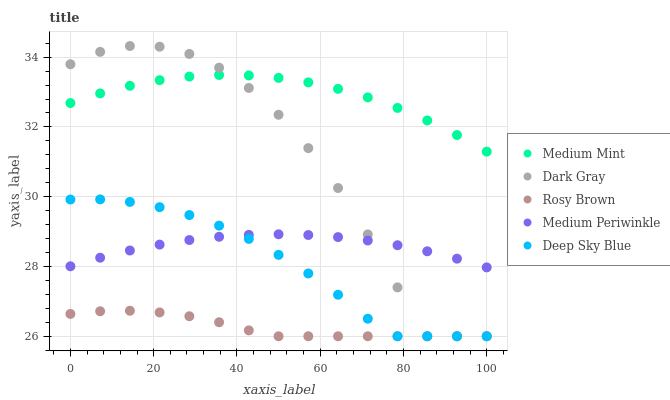Does Rosy Brown have the minimum area under the curve?
Answer yes or no. Yes. Does Medium Mint have the maximum area under the curve?
Answer yes or no. Yes. Does Dark Gray have the minimum area under the curve?
Answer yes or no. No. Does Dark Gray have the maximum area under the curve?
Answer yes or no. No. Is Medium Periwinkle the smoothest?
Answer yes or no. Yes. Is Dark Gray the roughest?
Answer yes or no. Yes. Is Rosy Brown the smoothest?
Answer yes or no. No. Is Rosy Brown the roughest?
Answer yes or no. No. Does Dark Gray have the lowest value?
Answer yes or no. Yes. Does Medium Periwinkle have the lowest value?
Answer yes or no. No. Does Dark Gray have the highest value?
Answer yes or no. Yes. Does Rosy Brown have the highest value?
Answer yes or no. No. Is Deep Sky Blue less than Medium Mint?
Answer yes or no. Yes. Is Medium Mint greater than Rosy Brown?
Answer yes or no. Yes. Does Deep Sky Blue intersect Dark Gray?
Answer yes or no. Yes. Is Deep Sky Blue less than Dark Gray?
Answer yes or no. No. Is Deep Sky Blue greater than Dark Gray?
Answer yes or no. No. Does Deep Sky Blue intersect Medium Mint?
Answer yes or no. No. 